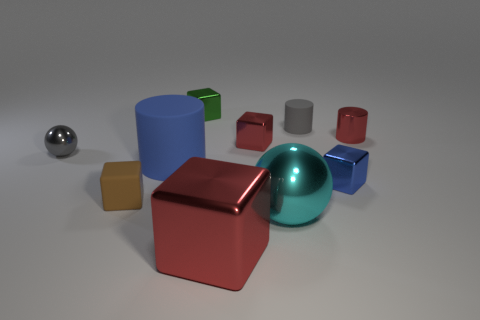What material is the ball on the right side of the red block in front of the large thing on the left side of the green shiny cube?
Offer a very short reply. Metal. Is the big matte cylinder the same color as the small ball?
Provide a succinct answer. No. Is there a large rubber object that has the same color as the large cylinder?
Make the answer very short. No. What shape is the brown rubber thing that is the same size as the red cylinder?
Provide a succinct answer. Cube. Is the number of purple balls less than the number of gray cylinders?
Offer a terse response. Yes. What number of other red cylinders have the same size as the red cylinder?
Offer a terse response. 0. The small metallic thing that is the same color as the large rubber cylinder is what shape?
Provide a short and direct response. Cube. What material is the brown cube?
Provide a succinct answer. Rubber. What is the size of the matte cylinder that is behind the tiny sphere?
Offer a terse response. Small. What number of big cyan shiny objects are the same shape as the small brown thing?
Give a very brief answer. 0. 